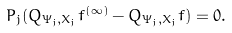Convert formula to latex. <formula><loc_0><loc_0><loc_500><loc_500>P _ { j } ( Q _ { \Psi _ { j } , X _ { j } } f ^ { ( \infty ) } - Q _ { \Psi _ { j } , X _ { j } } f ) = 0 .</formula> 